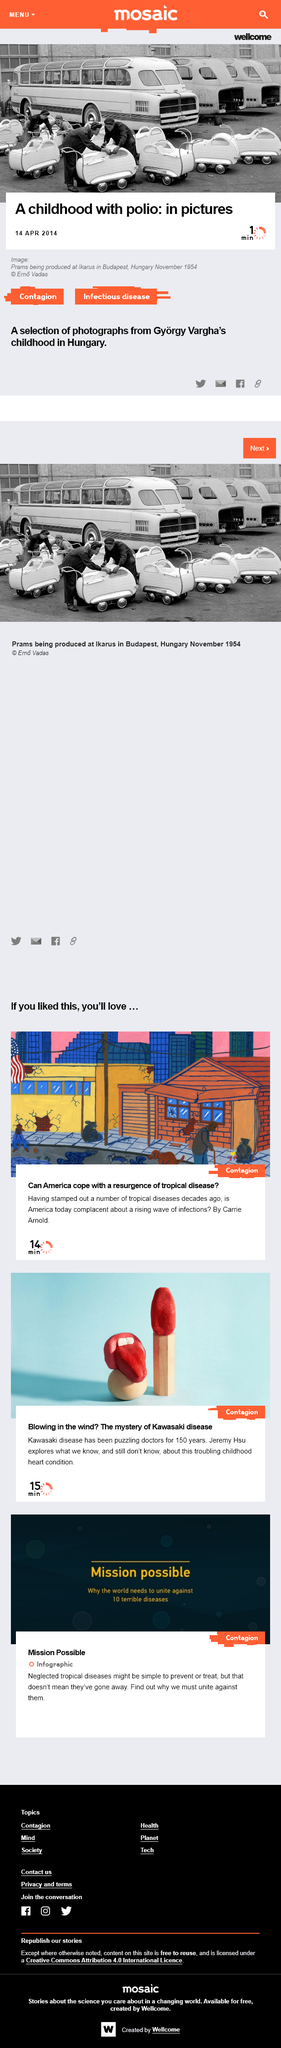Point out several critical features in this image. The prams in the image at the top of the page were produced at Ikarus in Budapest, Hungary. The image at the top of the page was taken in November 1954. The image at the top of the page was taken from the childhood of Gyorgy Vargha. 